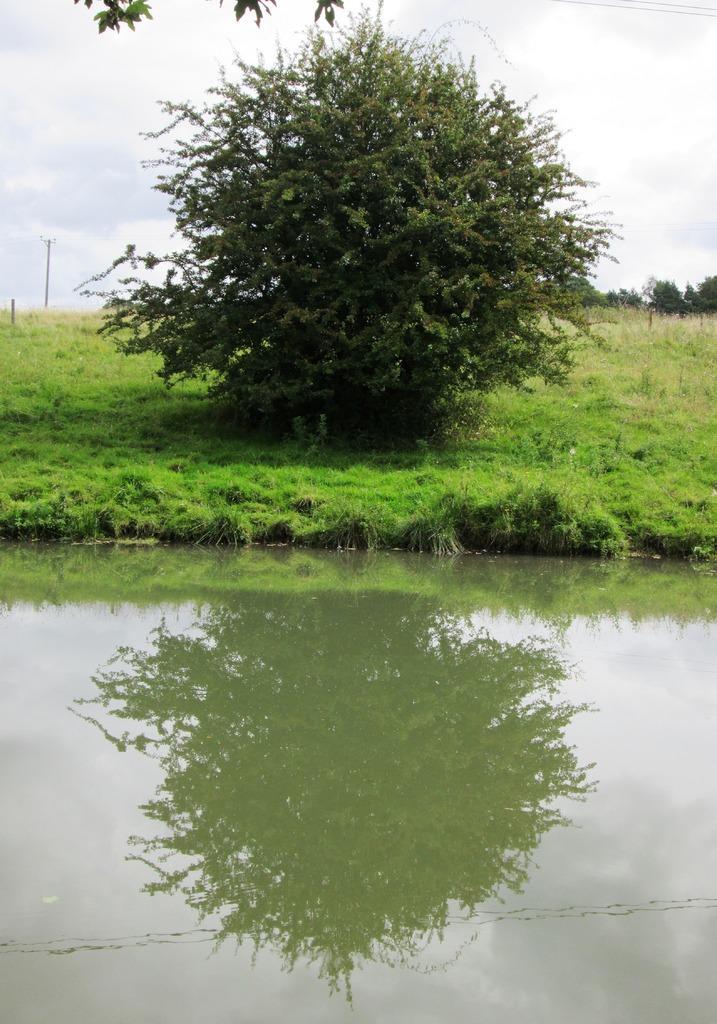How would you summarize this image in a sentence or two? In this image, we can see trees and poles on the ground and at the bottom, there is water. 